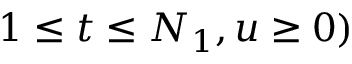<formula> <loc_0><loc_0><loc_500><loc_500>1 \leq t \leq N _ { 1 } , u \geq 0 )</formula> 